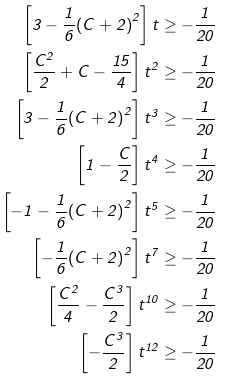<formula> <loc_0><loc_0><loc_500><loc_500>\left [ { 3 - \frac { 1 } { 6 } { ( C + 2 ) } ^ { 2 } } \right ] t \geq - \frac { 1 } { 2 0 } \\ \left [ { \frac { C ^ { 2 } } { 2 } + C - \frac { 1 5 } { 4 } } \right ] t ^ { 2 } \geq - \frac { 1 } { 2 0 } \\ \left [ { 3 - \frac { 1 } { 6 } { ( C + 2 ) } ^ { 2 } } \right ] t ^ { 3 } \geq - \frac { 1 } { 2 0 } \\ \left [ 1 - \frac { C } { 2 } \right ] t ^ { 4 } \geq - \frac { 1 } { 2 0 } \\ \left [ - 1 - \frac { 1 } { 6 } { ( C + 2 ) } ^ { 2 } \right ] t ^ { 5 } \geq - \frac { 1 } { 2 0 } \\ \left [ - \frac { 1 } { 6 } { ( C + 2 ) } ^ { 2 } \right ] t ^ { 7 } \geq - \frac { 1 } { 2 0 } \\ \left [ \frac { C ^ { 2 } } { 4 } - \frac { C ^ { 3 } } { 2 } \right ] t ^ { 1 0 } \geq - \frac { 1 } { 2 0 } \\ \left [ - \frac { C ^ { 3 } } { 2 } \right ] t ^ { 1 2 } \geq - \frac { 1 } { 2 0 }</formula> 